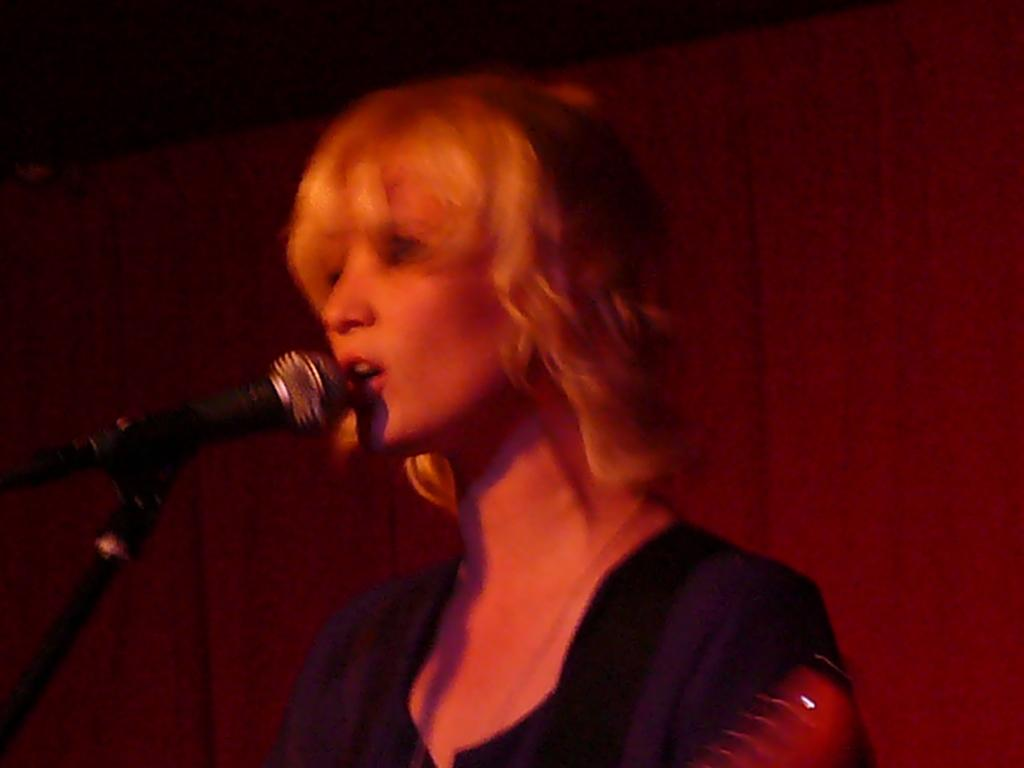What type of structure can be seen in the image? There is a wall in the image. What can be found on the wall in the image? There is a light in the image. What is the woman in the image holding? The woman is holding a mic in the image. What is the woman wearing in the image? The woman is wearing a black dress in the image. How many vases are present on the wall in the image? There are no vases present on the wall in the image. What type of apparatus is being used by the woman in the image? The woman is holding a mic in the image, not an apparatus. 